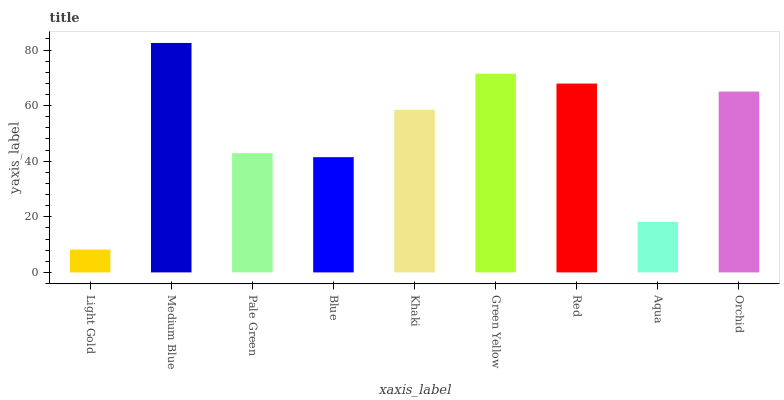Is Pale Green the minimum?
Answer yes or no. No. Is Pale Green the maximum?
Answer yes or no. No. Is Medium Blue greater than Pale Green?
Answer yes or no. Yes. Is Pale Green less than Medium Blue?
Answer yes or no. Yes. Is Pale Green greater than Medium Blue?
Answer yes or no. No. Is Medium Blue less than Pale Green?
Answer yes or no. No. Is Khaki the high median?
Answer yes or no. Yes. Is Khaki the low median?
Answer yes or no. Yes. Is Green Yellow the high median?
Answer yes or no. No. Is Red the low median?
Answer yes or no. No. 